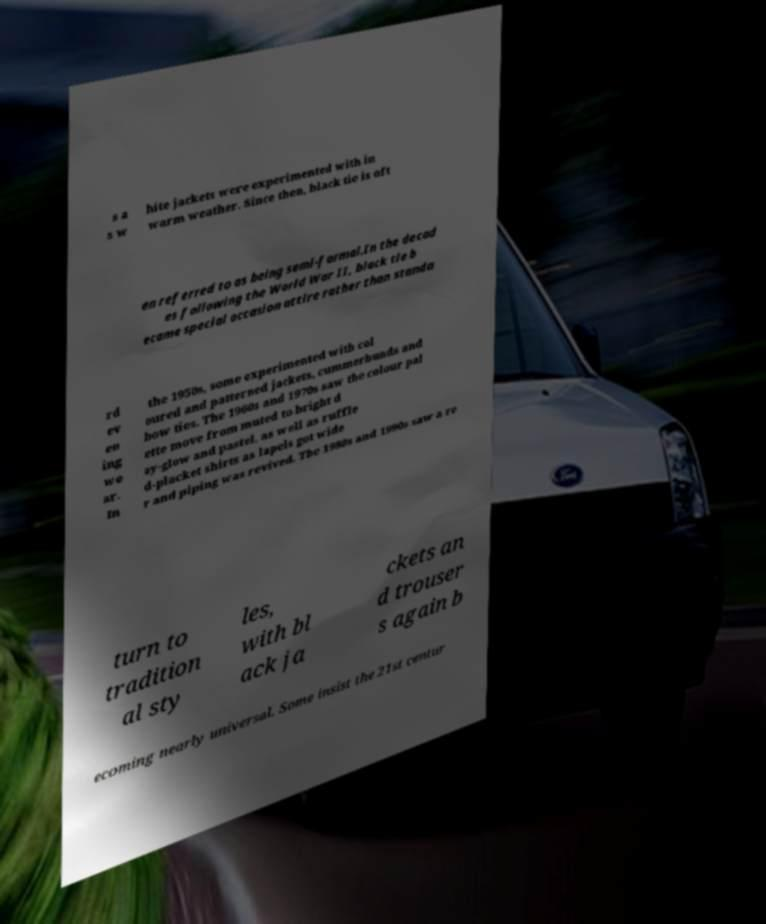Please identify and transcribe the text found in this image. s a s w hite jackets were experimented with in warm weather. Since then, black tie is oft en referred to as being semi-formal.In the decad es following the World War II, black tie b ecame special occasion attire rather than standa rd ev en ing we ar. In the 1950s, some experimented with col oured and patterned jackets, cummerbunds and bow ties. The 1960s and 1970s saw the colour pal ette move from muted to bright d ay-glow and pastel, as well as ruffle d-placket shirts as lapels got wide r and piping was revived. The 1980s and 1990s saw a re turn to tradition al sty les, with bl ack ja ckets an d trouser s again b ecoming nearly universal. Some insist the 21st centur 